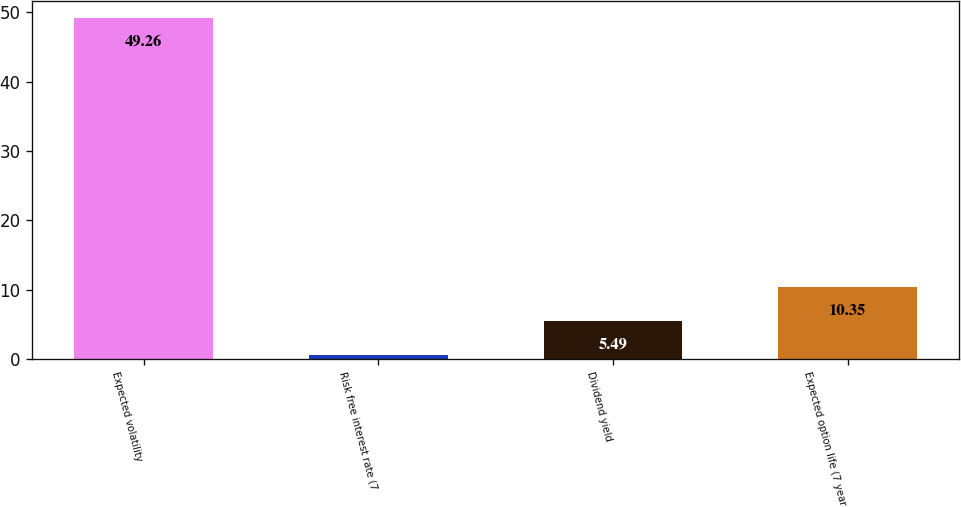Convert chart to OTSL. <chart><loc_0><loc_0><loc_500><loc_500><bar_chart><fcel>Expected volatility<fcel>Risk free interest rate (7<fcel>Dividend yield<fcel>Expected option life (7 year<nl><fcel>49.26<fcel>0.63<fcel>5.49<fcel>10.35<nl></chart> 